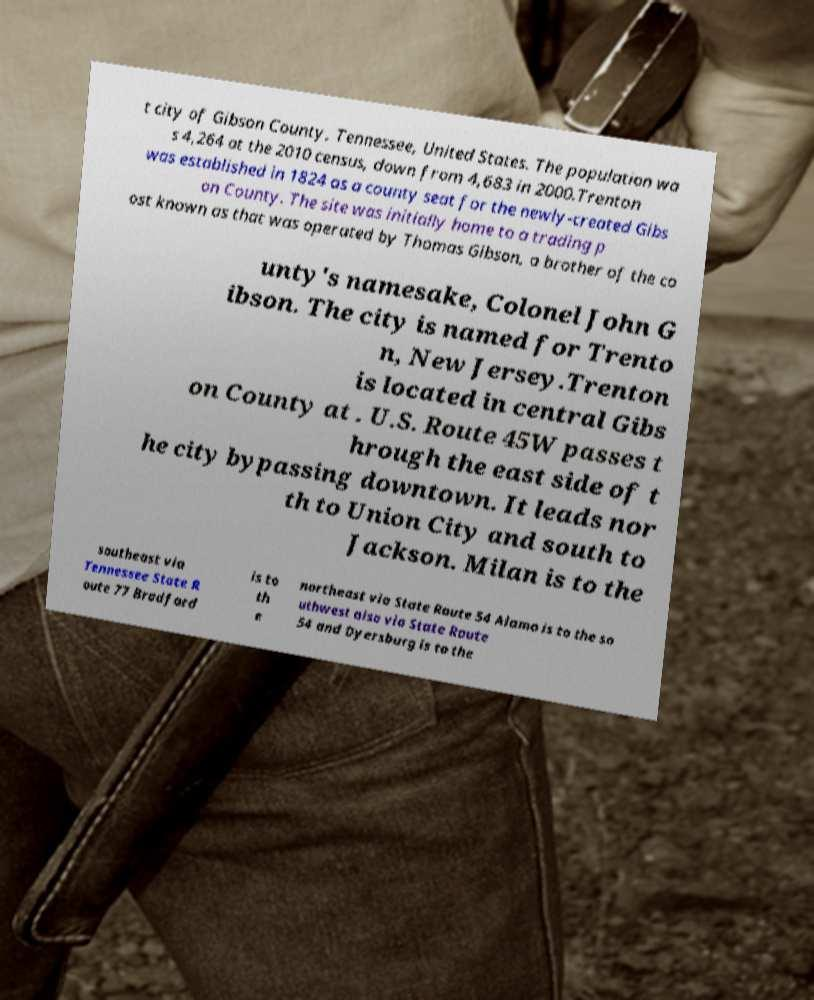I need the written content from this picture converted into text. Can you do that? t city of Gibson County, Tennessee, United States. The population wa s 4,264 at the 2010 census, down from 4,683 in 2000.Trenton was established in 1824 as a county seat for the newly-created Gibs on County. The site was initially home to a trading p ost known as that was operated by Thomas Gibson, a brother of the co unty's namesake, Colonel John G ibson. The city is named for Trento n, New Jersey.Trenton is located in central Gibs on County at . U.S. Route 45W passes t hrough the east side of t he city bypassing downtown. It leads nor th to Union City and south to Jackson. Milan is to the southeast via Tennessee State R oute 77 Bradford is to th e northeast via State Route 54 Alamo is to the so uthwest also via State Route 54 and Dyersburg is to the 